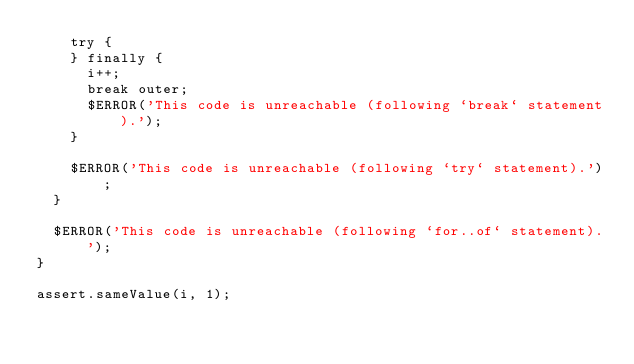<code> <loc_0><loc_0><loc_500><loc_500><_JavaScript_>    try {
    } finally {
      i++;
      break outer;
      $ERROR('This code is unreachable (following `break` statement).');
    }

    $ERROR('This code is unreachable (following `try` statement).');
  }

  $ERROR('This code is unreachable (following `for..of` statement).');
}

assert.sameValue(i, 1);
</code> 